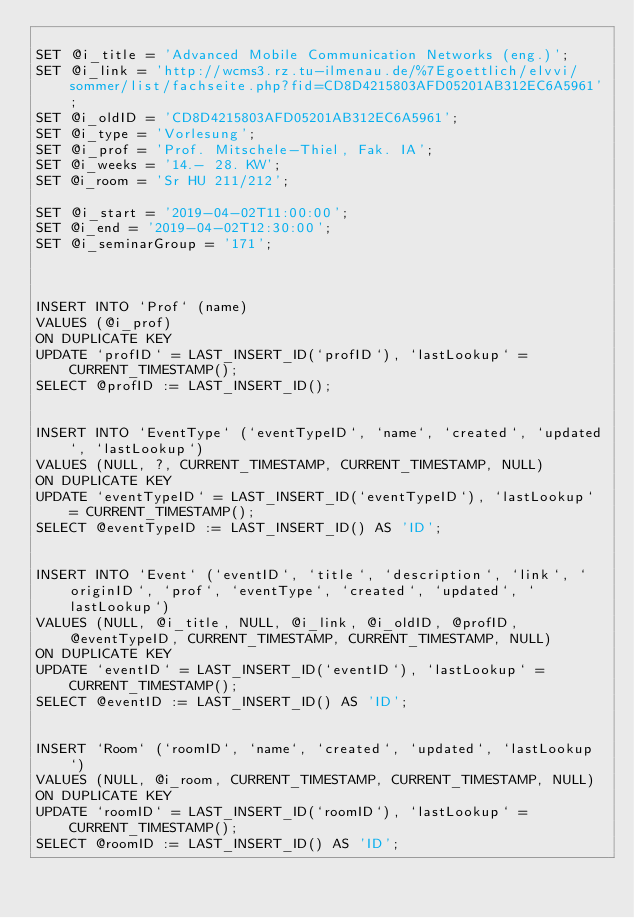<code> <loc_0><loc_0><loc_500><loc_500><_SQL_>
SET @i_title = 'Advanced Mobile Communication Networks (eng.)';
SET @i_link = 'http://wcms3.rz.tu-ilmenau.de/%7Egoettlich/elvvi/sommer/list/fachseite.php?fid=CD8D4215803AFD05201AB312EC6A5961';
SET @i_oldID = 'CD8D4215803AFD05201AB312EC6A5961';
SET @i_type = 'Vorlesung';
SET @i_prof = 'Prof. Mitschele-Thiel, Fak. IA';
SET @i_weeks = '14.- 28. KW';
SET @i_room = 'Sr HU 211/212';

SET @i_start = '2019-04-02T11:00:00';
SET @i_end = '2019-04-02T12:30:00';
SET @i_seminarGroup = '171';



INSERT INTO `Prof` (name) 
VALUES (@i_prof) 
ON DUPLICATE KEY 
UPDATE `profID` = LAST_INSERT_ID(`profID`), `lastLookup` = CURRENT_TIMESTAMP();
SELECT @profID := LAST_INSERT_ID();


INSERT INTO `EventType` (`eventTypeID`, `name`, `created`, `updated`, `lastLookup`) 
VALUES (NULL, ?, CURRENT_TIMESTAMP, CURRENT_TIMESTAMP, NULL) 
ON DUPLICATE KEY 
UPDATE `eventTypeID` = LAST_INSERT_ID(`eventTypeID`), `lastLookup` = CURRENT_TIMESTAMP();
SELECT @eventTypeID := LAST_INSERT_ID() AS 'ID';


INSERT INTO `Event` (`eventID`, `title`, `description`, `link`, `originID`, `prof`, `eventType`, `created`, `updated`, `lastLookup`) 
VALUES (NULL, @i_title, NULL, @i_link, @i_oldID, @profID, @eventTypeID, CURRENT_TIMESTAMP, CURRENT_TIMESTAMP, NULL)
ON DUPLICATE KEY 
UPDATE `eventID` = LAST_INSERT_ID(`eventID`), `lastLookup` = CURRENT_TIMESTAMP();
SELECT @eventID := LAST_INSERT_ID() AS 'ID';


INSERT `Room` (`roomID`, `name`, `created`, `updated`, `lastLookup`) 
VALUES (NULL, @i_room, CURRENT_TIMESTAMP, CURRENT_TIMESTAMP, NULL) 
ON DUPLICATE KEY 
UPDATE `roomID` = LAST_INSERT_ID(`roomID`), `lastLookup` = CURRENT_TIMESTAMP();
SELECT @roomID := LAST_INSERT_ID() AS 'ID';

</code> 